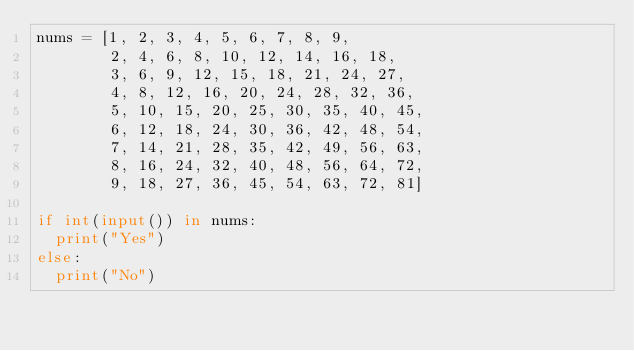<code> <loc_0><loc_0><loc_500><loc_500><_Python_>nums = [1, 2, 3, 4, 5, 6, 7, 8, 9,
        2, 4, 6, 8, 10, 12, 14, 16, 18,
        3, 6, 9, 12, 15, 18, 21, 24, 27,
        4, 8, 12, 16, 20, 24, 28, 32, 36,
        5, 10, 15, 20, 25, 30, 35, 40, 45,
        6, 12, 18, 24, 30, 36, 42, 48, 54,
        7, 14, 21, 28, 35, 42, 49, 56, 63,
        8, 16, 24, 32, 40, 48, 56, 64, 72,
        9, 18, 27, 36, 45, 54, 63, 72, 81]

if int(input()) in nums:
  print("Yes")
else:
  print("No")</code> 